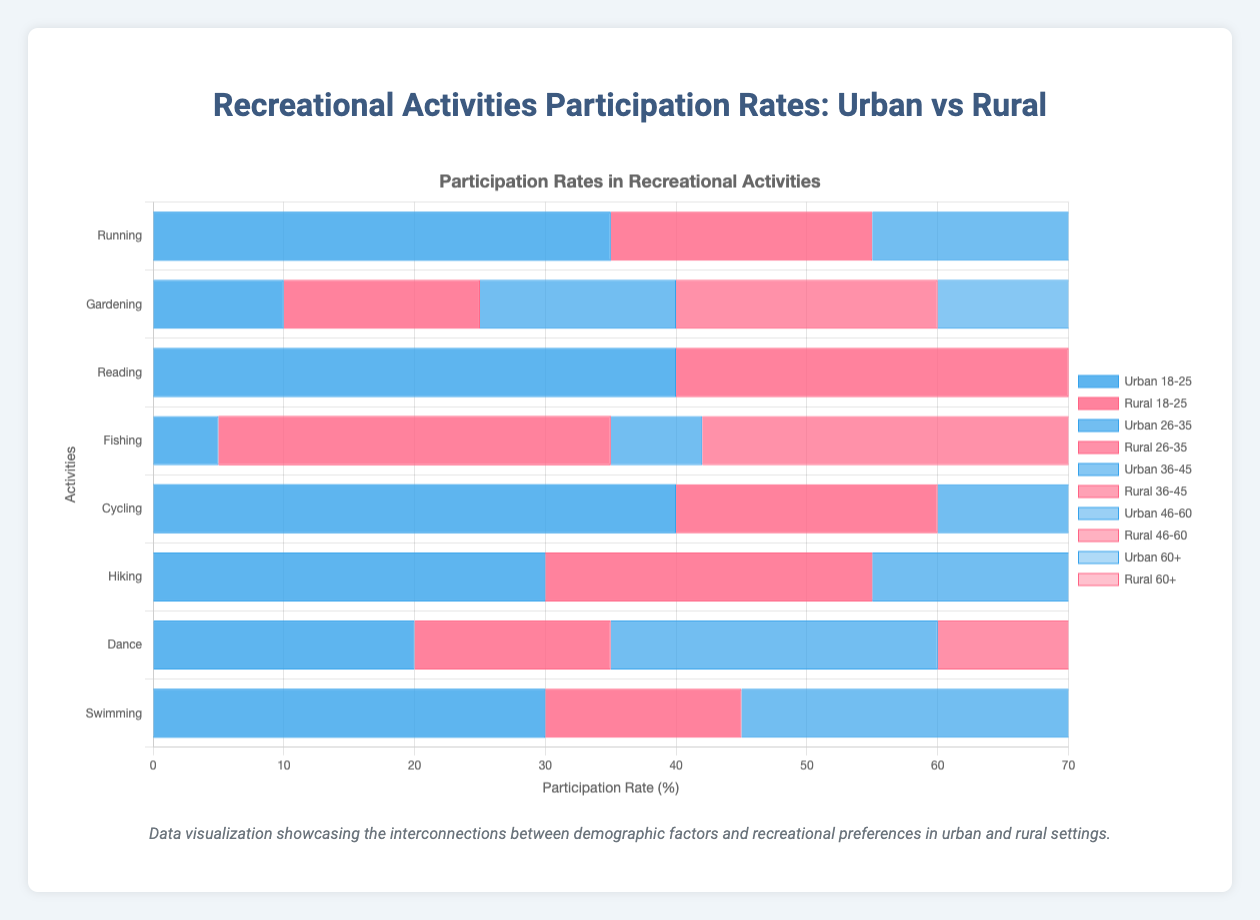What activity has the highest participation rate among urban 18-25-year-olds? From the chart, by looking for the tallest blue bar related to urban 18-25-year-olds, we can see that Reading has the highest participation rate among these age groups in the urban category.
Answer: Reading Which demographic group has the lowest participation rate in Hiking in rural areas? By comparing the height (or length, since it's horizontal) of the red bars for Hiking in rural areas, it is evident that the 60+ age group has the shortest bar, indicating the lowest participation rate.
Answer: 60+ How much higher is the urban participation rate in Cycling for the 18-25 age group compared to the 60+ age group? The urban participation rate for Cycling in the 18-25 age group is 40%, whereas for the 60+ age group, it is 20%. By subtracting 20% from 40%, we get the difference.
Answer: 20% Comparing Swimming, which area (urban or rural) has a higher participation rate for the 26-35 age group? By examining the chart's bars for Swimming, the urban bar for the 26-35 age group is taller than the rural bar, indicating a higher participation rate in urban areas for this age group.
Answer: Urban Which recreational activity shows the most significant difference in participation rates between urban and rural areas among the 46-60 age group? By observing the biggest difference between the heights of the corresponding bars for the 46-60 age group in both urban and rural areas, we can see Fishing has the most significant gap, with rural participation at 50% and urban at 15%.
Answer: Fishing What's the total participation rate of urban 18-25-year-olds in Running and Swimming combined? The urban 18-25 participation rate for Running is 35% and for Swimming is 30%. Adding these two rates gives 35% + 30% = 65%.
Answer: 65% In which activity does the 36-45 rural demographic group participate more compared to urban across the same age group? By comparing each activity's bar heights for the 36-45 age group in rural areas against the same in urban areas, we see that Fishing shows a higher participation rate in rural areas compared to urban.
Answer: Fishing What activity has the highest variation in participation rates within different age groups in urban areas? By examining the disparity in bar heights for different age groups within each activity in urban areas, we find that Gardening has the highest range of participation rates (from 10% in the 18-25 age group to 50% in the 60+ age group).
Answer: Gardening For Hiking, what is the average participation rate across all rural age groups? The participation rates for Hiking in rural areas are 25%, 22%, 20%, 15%, and 10%. The sum of these rates is 25 + 22 + 20 + 15 + 10 = 92. Dividing by the number of groups (5) gives 92 / 5 = 18.4%.
Answer: 18.4% Is the participation rate of urban 18-25-year-olds in Dance higher or lower than the participation rate of rural 18-25-year-olds in Reading? In the chart, the urban 18-25 participation rate for Dance is 20%, while the rural 18-25 participation rate for Reading is 30%. Therefore, the urban Dance rate is lower.
Answer: Lower 